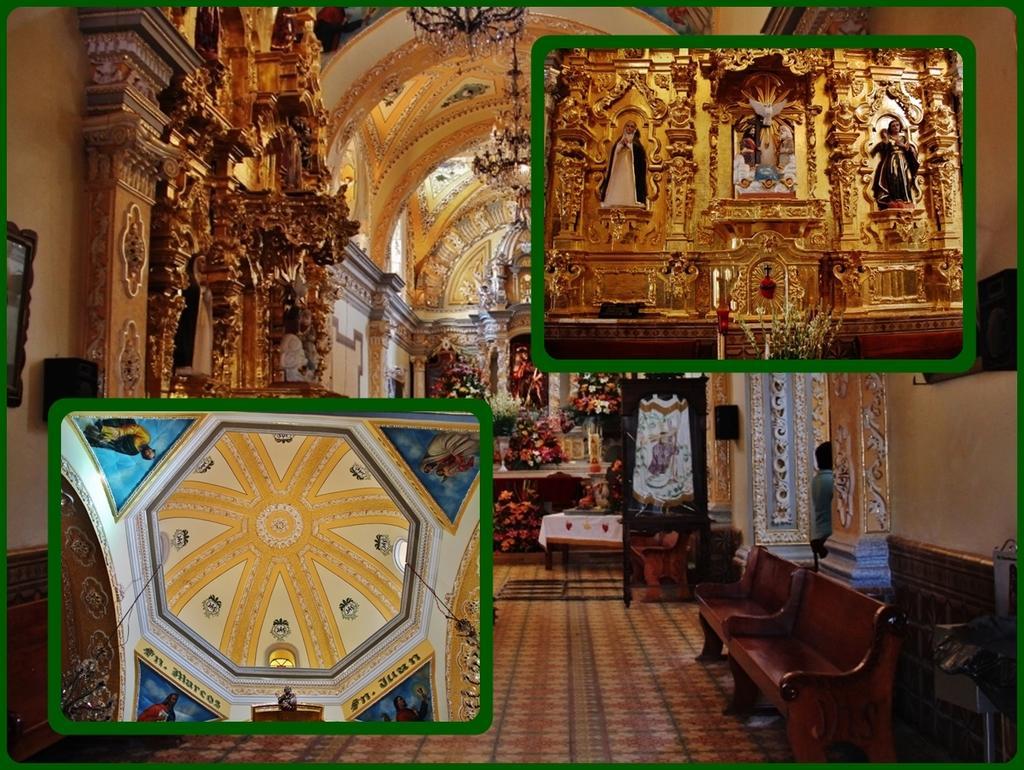How would you summarize this image in a sentence or two? In this image we can see an interior of the house. We can see a painting on the top of the house in one of the 3 images. A person is standing at the side of the image. 